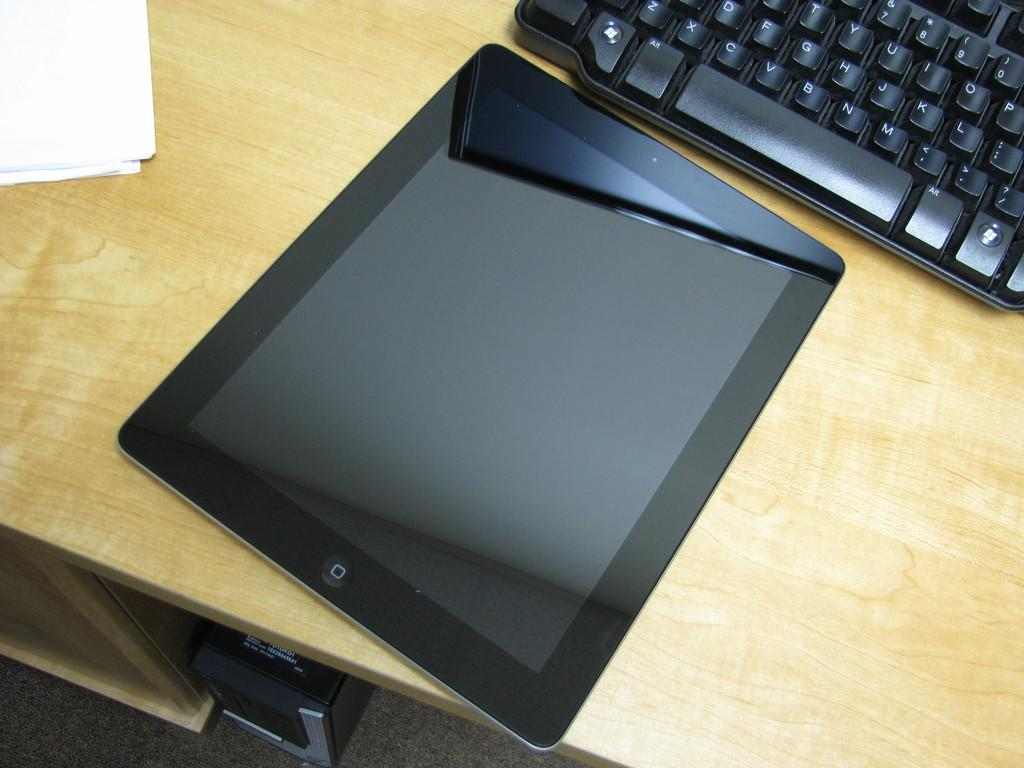Provide a one-sentence caption for the provided image. A black keyboard with an ALT key to the left of the space bar.sits behind an iPad. 